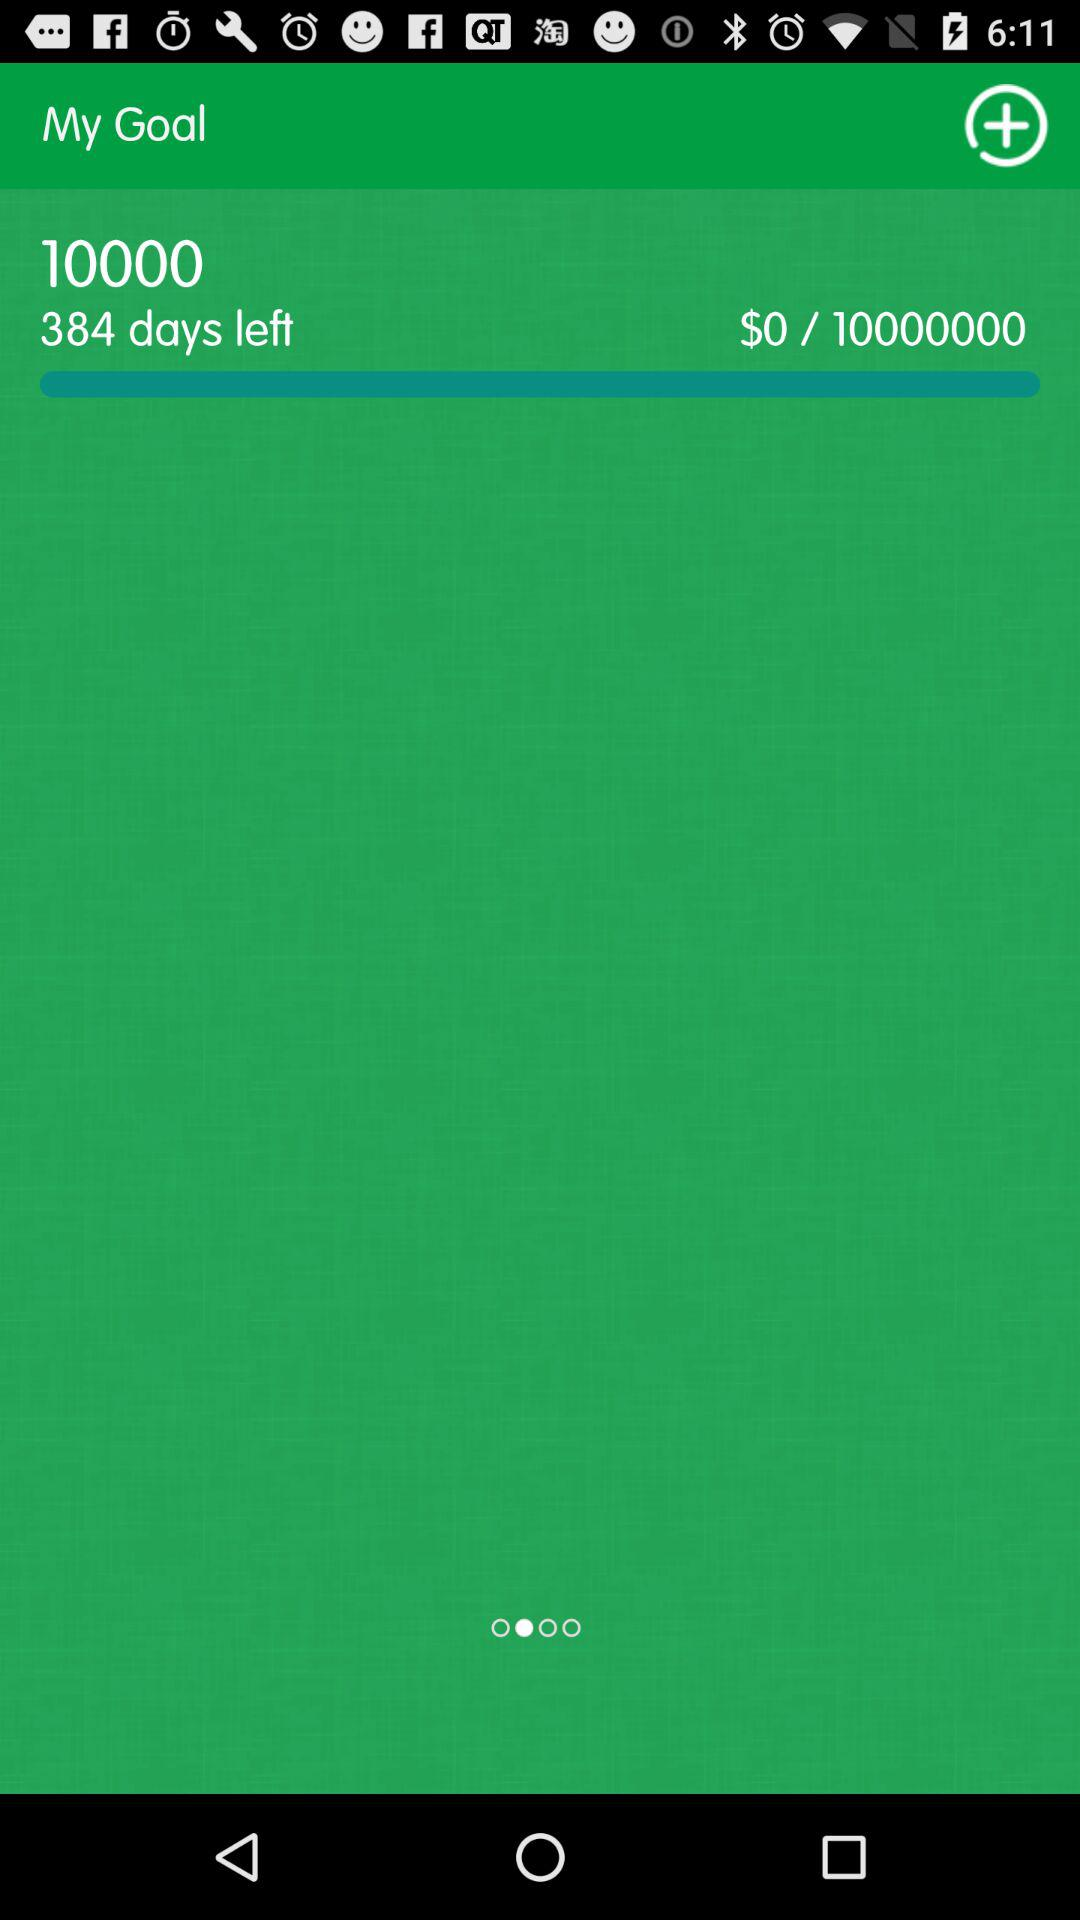Whose goals are these?
When the provided information is insufficient, respond with <no answer>. <no answer> 